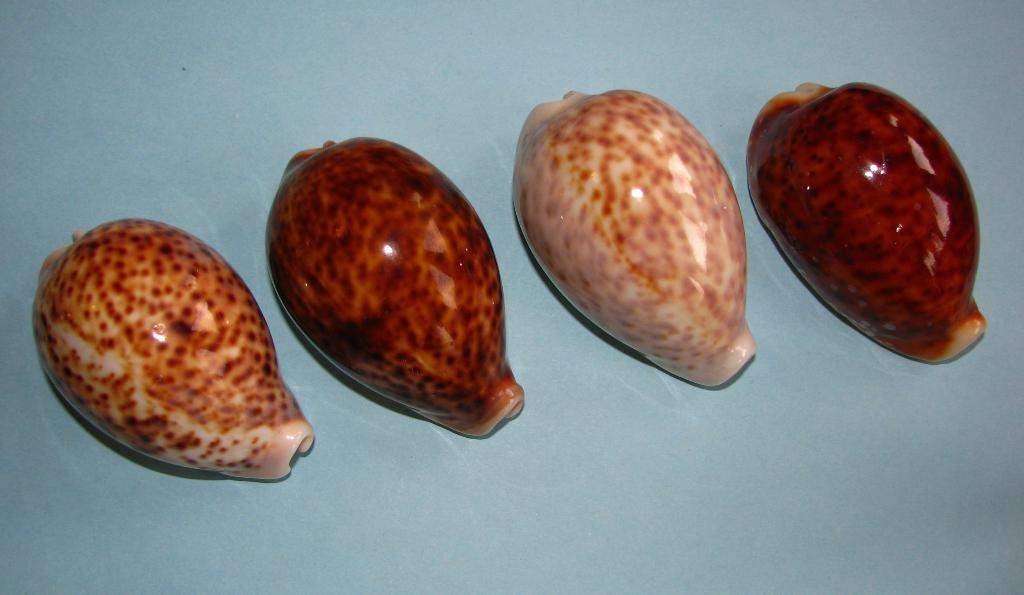What colors are the objects in the image? The objects in the image are in brown and cream color. What color is the background of the image? The background of the image is blue. How many bags can be seen in the image? There is no bag present in the image. Can you see a bee balancing on one of the objects in the image? There is no bee or any balancing act depicted in the image. 